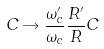Convert formula to latex. <formula><loc_0><loc_0><loc_500><loc_500>C \rightarrow \frac { \omega _ { c } ^ { \prime } } { \omega _ { c } } \frac { R ^ { \prime } } { R } C</formula> 